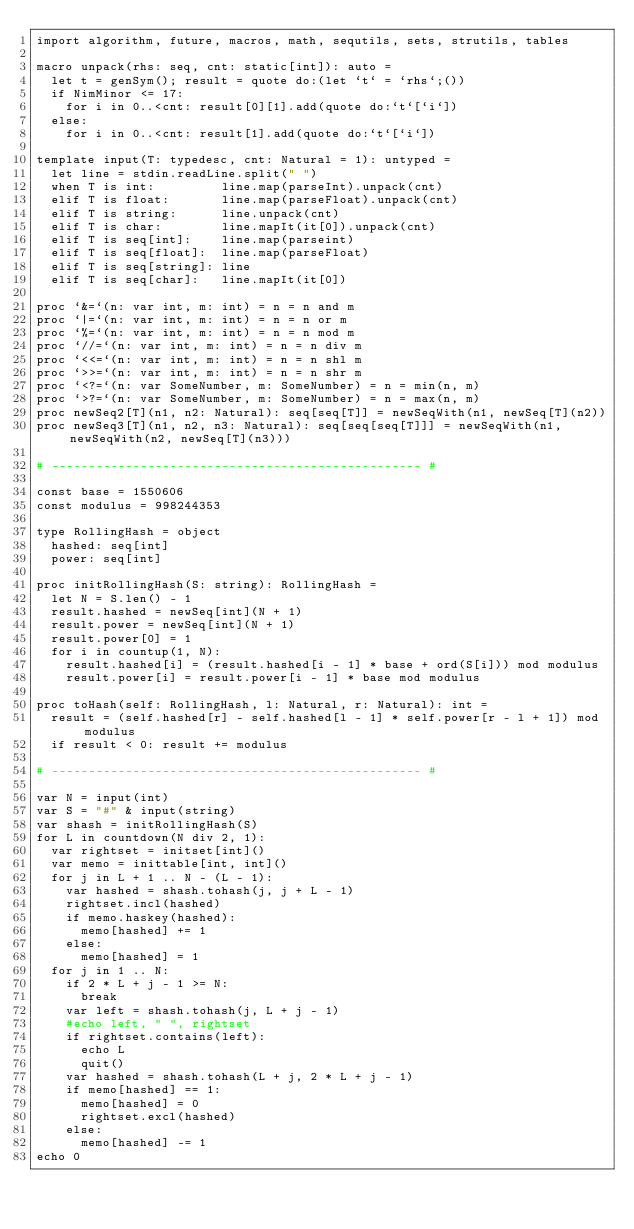Convert code to text. <code><loc_0><loc_0><loc_500><loc_500><_Nim_>import algorithm, future, macros, math, sequtils, sets, strutils, tables

macro unpack(rhs: seq, cnt: static[int]): auto =
  let t = genSym(); result = quote do:(let `t` = `rhs`;())
  if NimMinor <= 17:
    for i in 0..<cnt: result[0][1].add(quote do:`t`[`i`])
  else:
    for i in 0..<cnt: result[1].add(quote do:`t`[`i`])

template input(T: typedesc, cnt: Natural = 1): untyped =
  let line = stdin.readLine.split(" ")
  when T is int:         line.map(parseInt).unpack(cnt)
  elif T is float:       line.map(parseFloat).unpack(cnt)
  elif T is string:      line.unpack(cnt)
  elif T is char:        line.mapIt(it[0]).unpack(cnt)
  elif T is seq[int]:    line.map(parseint)
  elif T is seq[float]:  line.map(parseFloat)
  elif T is seq[string]: line
  elif T is seq[char]:   line.mapIt(it[0])

proc `&=`(n: var int, m: int) = n = n and m
proc `|=`(n: var int, m: int) = n = n or m
proc `%=`(n: var int, m: int) = n = n mod m
proc `//=`(n: var int, m: int) = n = n div m
proc `<<=`(n: var int, m: int) = n = n shl m
proc `>>=`(n: var int, m: int) = n = n shr m
proc `<?=`(n: var SomeNumber, m: SomeNumber) = n = min(n, m)
proc `>?=`(n: var SomeNumber, m: SomeNumber) = n = max(n, m)
proc newSeq2[T](n1, n2: Natural): seq[seq[T]] = newSeqWith(n1, newSeq[T](n2))
proc newSeq3[T](n1, n2, n3: Natural): seq[seq[seq[T]]] = newSeqWith(n1, newSeqWith(n2, newSeq[T](n3)))

# -------------------------------------------------- #

const base = 1550606
const modulus = 998244353

type RollingHash = object
  hashed: seq[int]
  power: seq[int]

proc initRollingHash(S: string): RollingHash =
  let N = S.len() - 1
  result.hashed = newSeq[int](N + 1)
  result.power = newSeq[int](N + 1)
  result.power[0] = 1
  for i in countup(1, N):
    result.hashed[i] = (result.hashed[i - 1] * base + ord(S[i])) mod modulus
    result.power[i] = result.power[i - 1] * base mod modulus

proc toHash(self: RollingHash, l: Natural, r: Natural): int =
  result = (self.hashed[r] - self.hashed[l - 1] * self.power[r - l + 1]) mod modulus
  if result < 0: result += modulus

# -------------------------------------------------- #

var N = input(int)
var S = "#" & input(string)
var shash = initRollingHash(S)
for L in countdown(N div 2, 1):
  var rightset = initset[int]()
  var memo = inittable[int, int]()
  for j in L + 1 .. N - (L - 1):
    var hashed = shash.tohash(j, j + L - 1)
    rightset.incl(hashed)
    if memo.haskey(hashed):
      memo[hashed] += 1
    else:
      memo[hashed] = 1
  for j in 1 .. N:
    if 2 * L + j - 1 >= N:
      break
    var left = shash.tohash(j, L + j - 1)
    #echo left, " ", rightset
    if rightset.contains(left):
      echo L
      quit()
    var hashed = shash.tohash(L + j, 2 * L + j - 1)
    if memo[hashed] == 1:
      memo[hashed] = 0
      rightset.excl(hashed)
    else:
      memo[hashed] -= 1
echo 0
</code> 